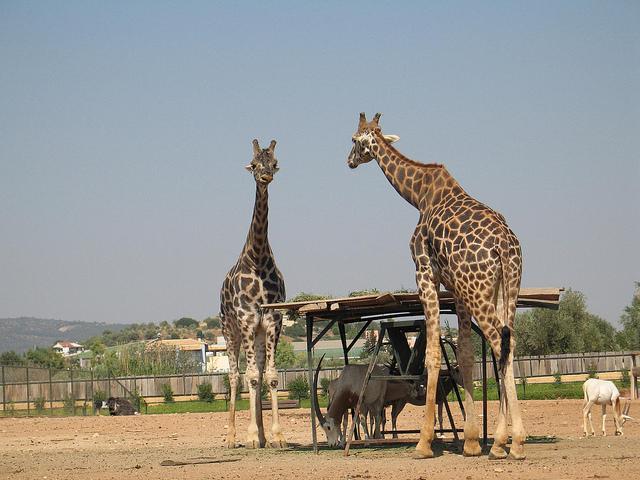What kind of animal is this?
Be succinct. Giraffe. Are the giraffes facing each other?
Short answer required. Yes. What's in the background of the image?
Write a very short answer. Trees. Are these animals  in a compound?
Be succinct. Yes. What other animals are in the photo?
Answer briefly. Goats. 